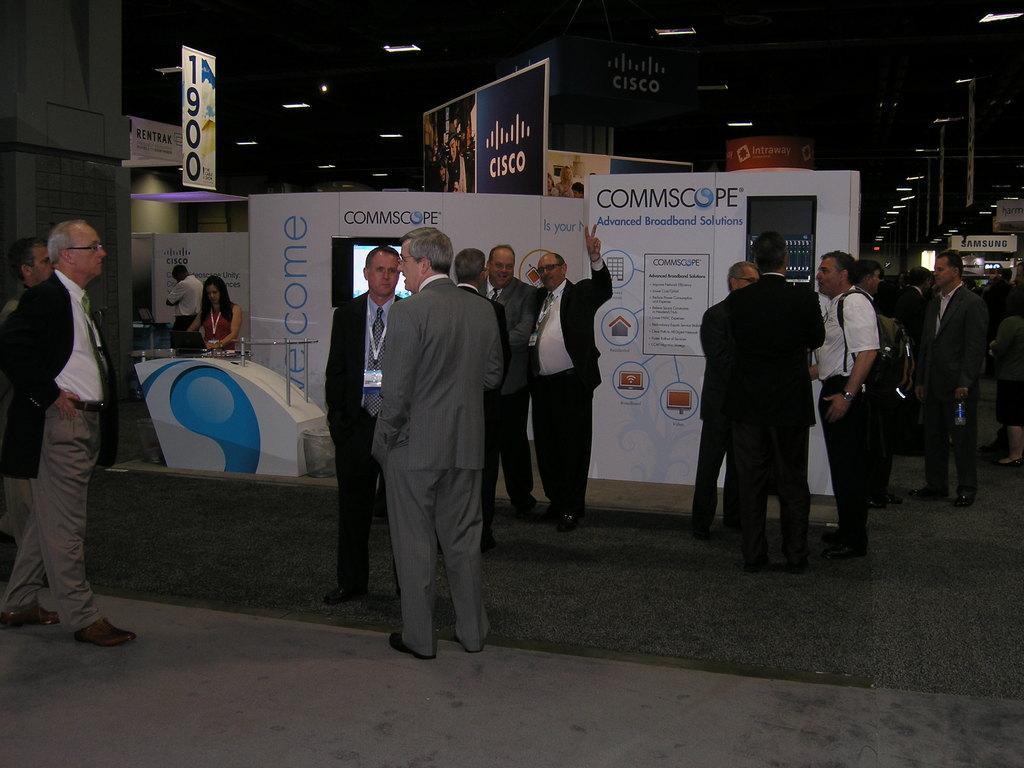Can you describe this image briefly? In this image we can see a few people standing, there are some boards with text and images, at the top we can see some lights to the ceiling and also we can see some poles with lights. 